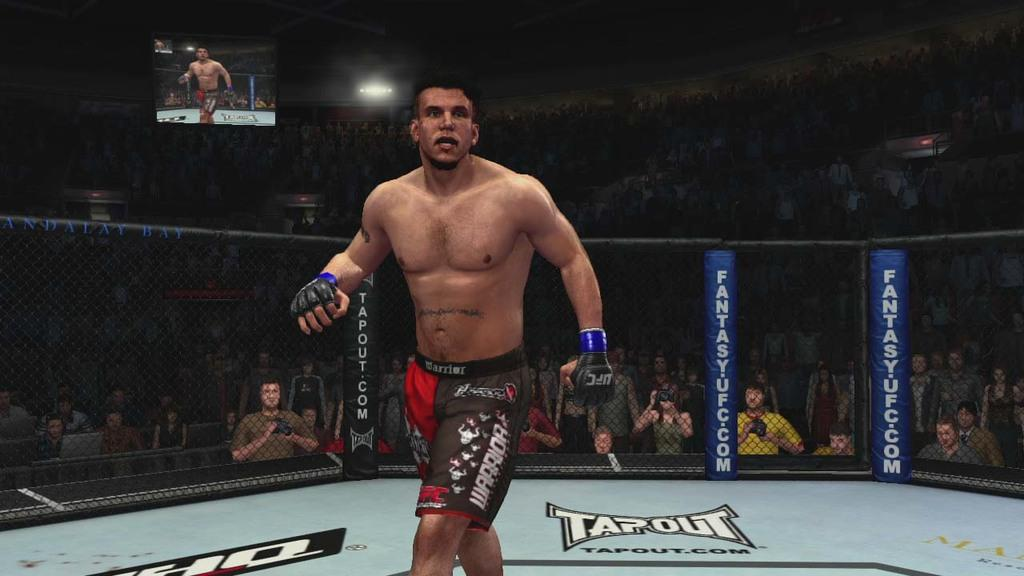<image>
Share a concise interpretation of the image provided. a male boxer walking around a boxing ring sponsored by tapout.com 